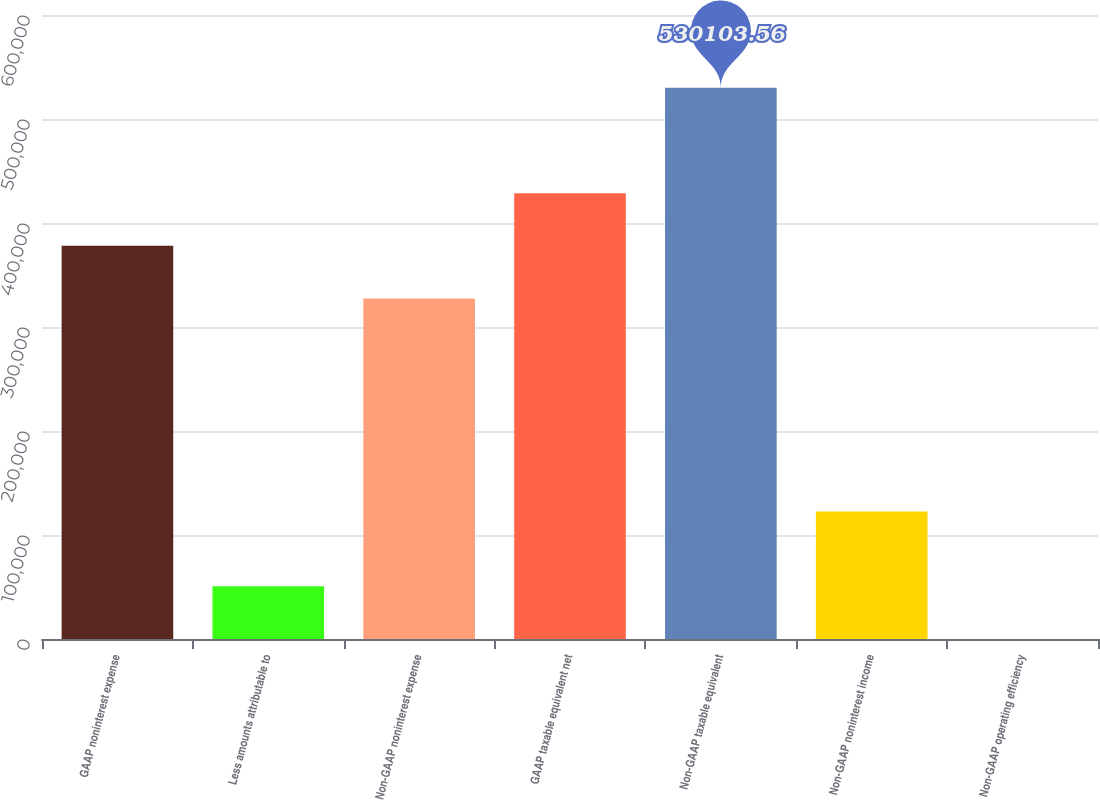<chart> <loc_0><loc_0><loc_500><loc_500><bar_chart><fcel>GAAP noninterest expense<fcel>Less amounts attributable to<fcel>Non-GAAP noninterest expense<fcel>GAAP taxable equivalent net<fcel>Non-GAAP taxable equivalent<fcel>Non-GAAP noninterest income<fcel>Non-GAAP operating efficiency<nl><fcel>378018<fcel>50759.7<fcel>327323<fcel>428713<fcel>530104<fcel>122644<fcel>64.56<nl></chart> 